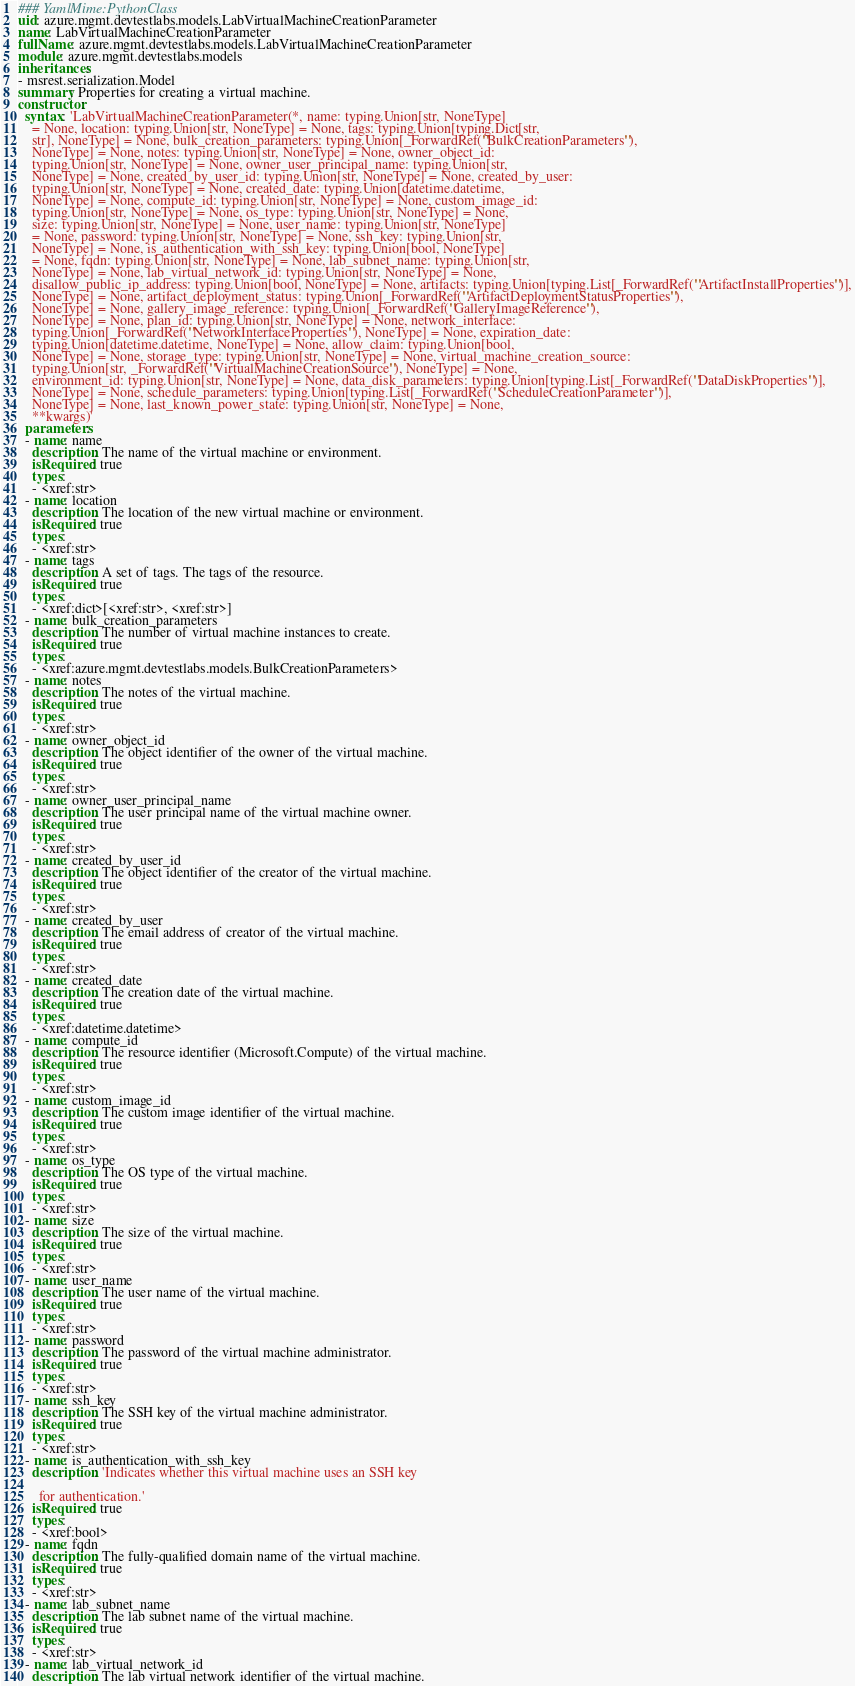Convert code to text. <code><loc_0><loc_0><loc_500><loc_500><_YAML_>### YamlMime:PythonClass
uid: azure.mgmt.devtestlabs.models.LabVirtualMachineCreationParameter
name: LabVirtualMachineCreationParameter
fullName: azure.mgmt.devtestlabs.models.LabVirtualMachineCreationParameter
module: azure.mgmt.devtestlabs.models
inheritances:
- msrest.serialization.Model
summary: Properties for creating a virtual machine.
constructor:
  syntax: 'LabVirtualMachineCreationParameter(*, name: typing.Union[str, NoneType]
    = None, location: typing.Union[str, NoneType] = None, tags: typing.Union[typing.Dict[str,
    str], NoneType] = None, bulk_creation_parameters: typing.Union[_ForwardRef(''BulkCreationParameters''),
    NoneType] = None, notes: typing.Union[str, NoneType] = None, owner_object_id:
    typing.Union[str, NoneType] = None, owner_user_principal_name: typing.Union[str,
    NoneType] = None, created_by_user_id: typing.Union[str, NoneType] = None, created_by_user:
    typing.Union[str, NoneType] = None, created_date: typing.Union[datetime.datetime,
    NoneType] = None, compute_id: typing.Union[str, NoneType] = None, custom_image_id:
    typing.Union[str, NoneType] = None, os_type: typing.Union[str, NoneType] = None,
    size: typing.Union[str, NoneType] = None, user_name: typing.Union[str, NoneType]
    = None, password: typing.Union[str, NoneType] = None, ssh_key: typing.Union[str,
    NoneType] = None, is_authentication_with_ssh_key: typing.Union[bool, NoneType]
    = None, fqdn: typing.Union[str, NoneType] = None, lab_subnet_name: typing.Union[str,
    NoneType] = None, lab_virtual_network_id: typing.Union[str, NoneType] = None,
    disallow_public_ip_address: typing.Union[bool, NoneType] = None, artifacts: typing.Union[typing.List[_ForwardRef(''ArtifactInstallProperties'')],
    NoneType] = None, artifact_deployment_status: typing.Union[_ForwardRef(''ArtifactDeploymentStatusProperties''),
    NoneType] = None, gallery_image_reference: typing.Union[_ForwardRef(''GalleryImageReference''),
    NoneType] = None, plan_id: typing.Union[str, NoneType] = None, network_interface:
    typing.Union[_ForwardRef(''NetworkInterfaceProperties''), NoneType] = None, expiration_date:
    typing.Union[datetime.datetime, NoneType] = None, allow_claim: typing.Union[bool,
    NoneType] = None, storage_type: typing.Union[str, NoneType] = None, virtual_machine_creation_source:
    typing.Union[str, _ForwardRef(''VirtualMachineCreationSource''), NoneType] = None,
    environment_id: typing.Union[str, NoneType] = None, data_disk_parameters: typing.Union[typing.List[_ForwardRef(''DataDiskProperties'')],
    NoneType] = None, schedule_parameters: typing.Union[typing.List[_ForwardRef(''ScheduleCreationParameter'')],
    NoneType] = None, last_known_power_state: typing.Union[str, NoneType] = None,
    **kwargs)'
  parameters:
  - name: name
    description: The name of the virtual machine or environment.
    isRequired: true
    types:
    - <xref:str>
  - name: location
    description: The location of the new virtual machine or environment.
    isRequired: true
    types:
    - <xref:str>
  - name: tags
    description: A set of tags. The tags of the resource.
    isRequired: true
    types:
    - <xref:dict>[<xref:str>, <xref:str>]
  - name: bulk_creation_parameters
    description: The number of virtual machine instances to create.
    isRequired: true
    types:
    - <xref:azure.mgmt.devtestlabs.models.BulkCreationParameters>
  - name: notes
    description: The notes of the virtual machine.
    isRequired: true
    types:
    - <xref:str>
  - name: owner_object_id
    description: The object identifier of the owner of the virtual machine.
    isRequired: true
    types:
    - <xref:str>
  - name: owner_user_principal_name
    description: The user principal name of the virtual machine owner.
    isRequired: true
    types:
    - <xref:str>
  - name: created_by_user_id
    description: The object identifier of the creator of the virtual machine.
    isRequired: true
    types:
    - <xref:str>
  - name: created_by_user
    description: The email address of creator of the virtual machine.
    isRequired: true
    types:
    - <xref:str>
  - name: created_date
    description: The creation date of the virtual machine.
    isRequired: true
    types:
    - <xref:datetime.datetime>
  - name: compute_id
    description: The resource identifier (Microsoft.Compute) of the virtual machine.
    isRequired: true
    types:
    - <xref:str>
  - name: custom_image_id
    description: The custom image identifier of the virtual machine.
    isRequired: true
    types:
    - <xref:str>
  - name: os_type
    description: The OS type of the virtual machine.
    isRequired: true
    types:
    - <xref:str>
  - name: size
    description: The size of the virtual machine.
    isRequired: true
    types:
    - <xref:str>
  - name: user_name
    description: The user name of the virtual machine.
    isRequired: true
    types:
    - <xref:str>
  - name: password
    description: The password of the virtual machine administrator.
    isRequired: true
    types:
    - <xref:str>
  - name: ssh_key
    description: The SSH key of the virtual machine administrator.
    isRequired: true
    types:
    - <xref:str>
  - name: is_authentication_with_ssh_key
    description: 'Indicates whether this virtual machine uses an SSH key

      for authentication.'
    isRequired: true
    types:
    - <xref:bool>
  - name: fqdn
    description: The fully-qualified domain name of the virtual machine.
    isRequired: true
    types:
    - <xref:str>
  - name: lab_subnet_name
    description: The lab subnet name of the virtual machine.
    isRequired: true
    types:
    - <xref:str>
  - name: lab_virtual_network_id
    description: The lab virtual network identifier of the virtual machine.</code> 